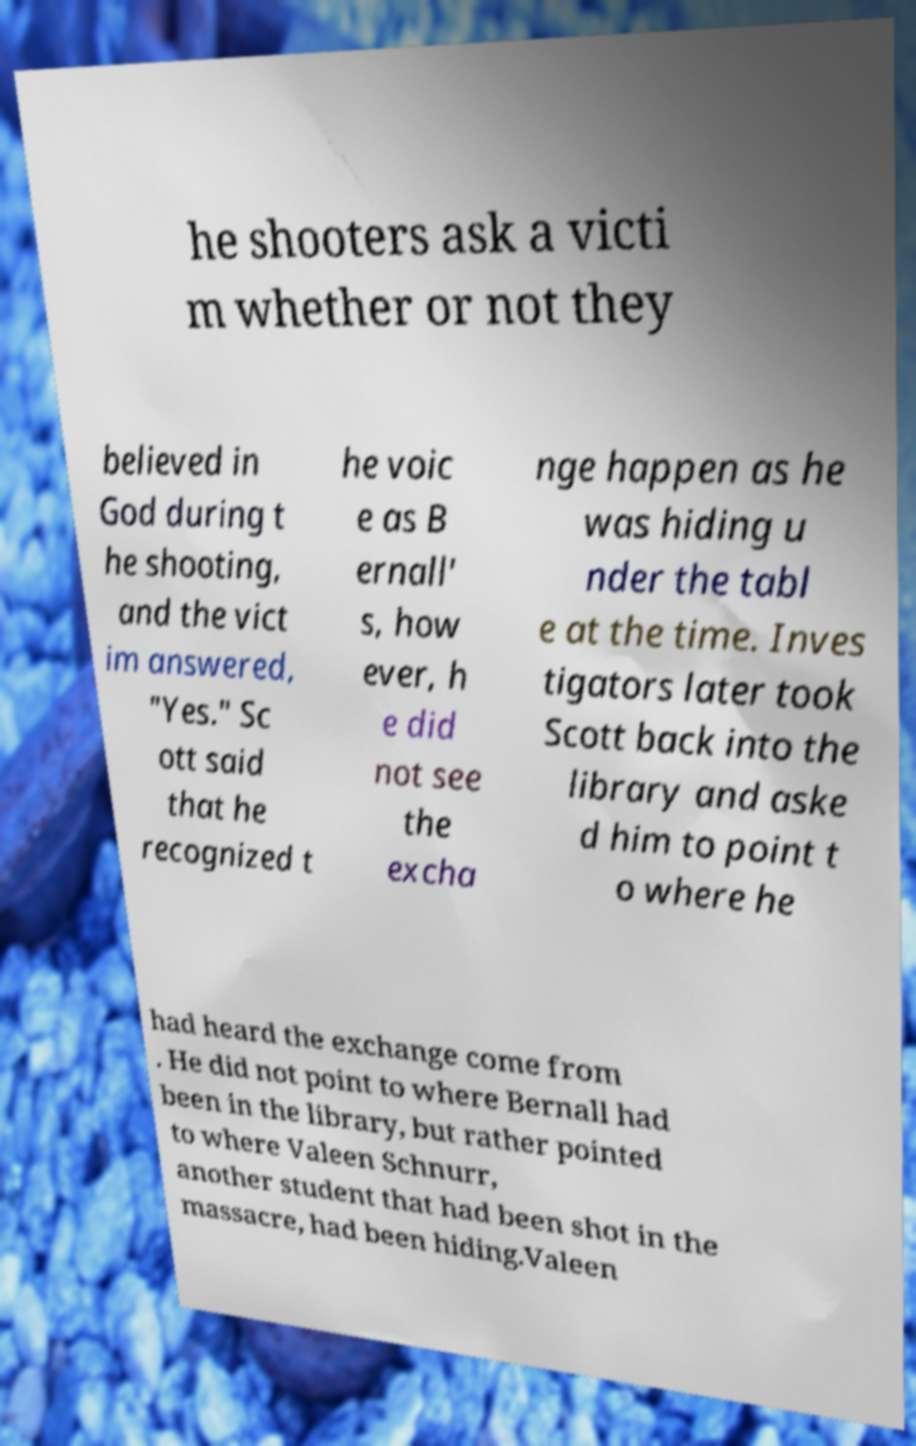Could you extract and type out the text from this image? he shooters ask a victi m whether or not they believed in God during t he shooting, and the vict im answered, "Yes." Sc ott said that he recognized t he voic e as B ernall' s, how ever, h e did not see the excha nge happen as he was hiding u nder the tabl e at the time. Inves tigators later took Scott back into the library and aske d him to point t o where he had heard the exchange come from . He did not point to where Bernall had been in the library, but rather pointed to where Valeen Schnurr, another student that had been shot in the massacre, had been hiding.Valeen 